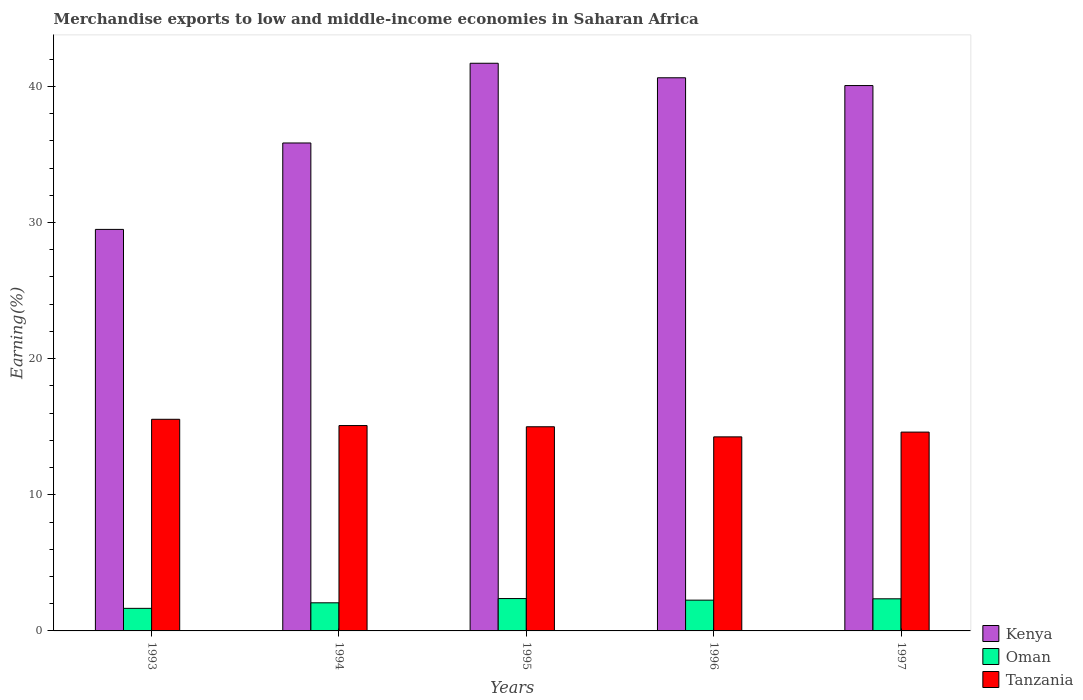How many groups of bars are there?
Give a very brief answer. 5. Are the number of bars on each tick of the X-axis equal?
Offer a very short reply. Yes. How many bars are there on the 2nd tick from the left?
Your answer should be compact. 3. How many bars are there on the 2nd tick from the right?
Keep it short and to the point. 3. What is the percentage of amount earned from merchandise exports in Oman in 1997?
Give a very brief answer. 2.36. Across all years, what is the maximum percentage of amount earned from merchandise exports in Kenya?
Ensure brevity in your answer.  41.7. Across all years, what is the minimum percentage of amount earned from merchandise exports in Oman?
Your answer should be very brief. 1.66. In which year was the percentage of amount earned from merchandise exports in Tanzania maximum?
Your response must be concise. 1993. In which year was the percentage of amount earned from merchandise exports in Tanzania minimum?
Provide a short and direct response. 1996. What is the total percentage of amount earned from merchandise exports in Oman in the graph?
Ensure brevity in your answer.  10.72. What is the difference between the percentage of amount earned from merchandise exports in Tanzania in 1994 and that in 1996?
Keep it short and to the point. 0.83. What is the difference between the percentage of amount earned from merchandise exports in Tanzania in 1993 and the percentage of amount earned from merchandise exports in Oman in 1997?
Ensure brevity in your answer.  13.19. What is the average percentage of amount earned from merchandise exports in Kenya per year?
Keep it short and to the point. 37.55. In the year 1993, what is the difference between the percentage of amount earned from merchandise exports in Kenya and percentage of amount earned from merchandise exports in Oman?
Your answer should be compact. 27.84. What is the ratio of the percentage of amount earned from merchandise exports in Tanzania in 1993 to that in 1997?
Give a very brief answer. 1.06. Is the percentage of amount earned from merchandise exports in Tanzania in 1995 less than that in 1997?
Your answer should be compact. No. What is the difference between the highest and the second highest percentage of amount earned from merchandise exports in Tanzania?
Provide a succinct answer. 0.46. What is the difference between the highest and the lowest percentage of amount earned from merchandise exports in Oman?
Keep it short and to the point. 0.72. In how many years, is the percentage of amount earned from merchandise exports in Oman greater than the average percentage of amount earned from merchandise exports in Oman taken over all years?
Provide a short and direct response. 3. Is the sum of the percentage of amount earned from merchandise exports in Kenya in 1996 and 1997 greater than the maximum percentage of amount earned from merchandise exports in Tanzania across all years?
Provide a short and direct response. Yes. What does the 2nd bar from the left in 1997 represents?
Offer a terse response. Oman. What does the 3rd bar from the right in 1995 represents?
Your answer should be very brief. Kenya. Is it the case that in every year, the sum of the percentage of amount earned from merchandise exports in Oman and percentage of amount earned from merchandise exports in Tanzania is greater than the percentage of amount earned from merchandise exports in Kenya?
Your answer should be very brief. No. What is the difference between two consecutive major ticks on the Y-axis?
Your answer should be compact. 10. Are the values on the major ticks of Y-axis written in scientific E-notation?
Make the answer very short. No. Does the graph contain any zero values?
Offer a terse response. No. Does the graph contain grids?
Make the answer very short. No. Where does the legend appear in the graph?
Give a very brief answer. Bottom right. What is the title of the graph?
Offer a very short reply. Merchandise exports to low and middle-income economies in Saharan Africa. Does "Virgin Islands" appear as one of the legend labels in the graph?
Make the answer very short. No. What is the label or title of the X-axis?
Ensure brevity in your answer.  Years. What is the label or title of the Y-axis?
Offer a very short reply. Earning(%). What is the Earning(%) in Kenya in 1993?
Your answer should be very brief. 29.49. What is the Earning(%) of Oman in 1993?
Offer a terse response. 1.66. What is the Earning(%) in Tanzania in 1993?
Give a very brief answer. 15.55. What is the Earning(%) in Kenya in 1994?
Your response must be concise. 35.84. What is the Earning(%) of Oman in 1994?
Offer a very short reply. 2.07. What is the Earning(%) in Tanzania in 1994?
Make the answer very short. 15.09. What is the Earning(%) in Kenya in 1995?
Offer a terse response. 41.7. What is the Earning(%) in Oman in 1995?
Provide a short and direct response. 2.38. What is the Earning(%) of Tanzania in 1995?
Offer a very short reply. 15. What is the Earning(%) in Kenya in 1996?
Offer a very short reply. 40.63. What is the Earning(%) of Oman in 1996?
Your response must be concise. 2.26. What is the Earning(%) of Tanzania in 1996?
Offer a terse response. 14.25. What is the Earning(%) of Kenya in 1997?
Offer a very short reply. 40.06. What is the Earning(%) of Oman in 1997?
Keep it short and to the point. 2.36. What is the Earning(%) of Tanzania in 1997?
Give a very brief answer. 14.61. Across all years, what is the maximum Earning(%) of Kenya?
Make the answer very short. 41.7. Across all years, what is the maximum Earning(%) of Oman?
Ensure brevity in your answer.  2.38. Across all years, what is the maximum Earning(%) of Tanzania?
Provide a succinct answer. 15.55. Across all years, what is the minimum Earning(%) of Kenya?
Ensure brevity in your answer.  29.49. Across all years, what is the minimum Earning(%) in Oman?
Provide a short and direct response. 1.66. Across all years, what is the minimum Earning(%) of Tanzania?
Your response must be concise. 14.25. What is the total Earning(%) in Kenya in the graph?
Keep it short and to the point. 187.73. What is the total Earning(%) of Oman in the graph?
Offer a very short reply. 10.72. What is the total Earning(%) of Tanzania in the graph?
Ensure brevity in your answer.  74.49. What is the difference between the Earning(%) in Kenya in 1993 and that in 1994?
Ensure brevity in your answer.  -6.35. What is the difference between the Earning(%) of Oman in 1993 and that in 1994?
Your answer should be compact. -0.41. What is the difference between the Earning(%) in Tanzania in 1993 and that in 1994?
Provide a succinct answer. 0.46. What is the difference between the Earning(%) of Kenya in 1993 and that in 1995?
Ensure brevity in your answer.  -12.2. What is the difference between the Earning(%) in Oman in 1993 and that in 1995?
Your answer should be compact. -0.72. What is the difference between the Earning(%) in Tanzania in 1993 and that in 1995?
Make the answer very short. 0.55. What is the difference between the Earning(%) in Kenya in 1993 and that in 1996?
Your answer should be compact. -11.14. What is the difference between the Earning(%) in Oman in 1993 and that in 1996?
Offer a very short reply. -0.6. What is the difference between the Earning(%) in Tanzania in 1993 and that in 1996?
Give a very brief answer. 1.29. What is the difference between the Earning(%) of Kenya in 1993 and that in 1997?
Give a very brief answer. -10.57. What is the difference between the Earning(%) in Oman in 1993 and that in 1997?
Your answer should be very brief. -0.7. What is the difference between the Earning(%) of Tanzania in 1993 and that in 1997?
Your response must be concise. 0.94. What is the difference between the Earning(%) of Kenya in 1994 and that in 1995?
Your answer should be very brief. -5.86. What is the difference between the Earning(%) in Oman in 1994 and that in 1995?
Give a very brief answer. -0.31. What is the difference between the Earning(%) of Tanzania in 1994 and that in 1995?
Provide a succinct answer. 0.09. What is the difference between the Earning(%) in Kenya in 1994 and that in 1996?
Provide a short and direct response. -4.79. What is the difference between the Earning(%) in Oman in 1994 and that in 1996?
Make the answer very short. -0.2. What is the difference between the Earning(%) in Tanzania in 1994 and that in 1996?
Keep it short and to the point. 0.83. What is the difference between the Earning(%) of Kenya in 1994 and that in 1997?
Give a very brief answer. -4.22. What is the difference between the Earning(%) of Oman in 1994 and that in 1997?
Provide a succinct answer. -0.29. What is the difference between the Earning(%) in Tanzania in 1994 and that in 1997?
Give a very brief answer. 0.48. What is the difference between the Earning(%) of Kenya in 1995 and that in 1996?
Provide a short and direct response. 1.07. What is the difference between the Earning(%) of Oman in 1995 and that in 1996?
Make the answer very short. 0.12. What is the difference between the Earning(%) of Tanzania in 1995 and that in 1996?
Your response must be concise. 0.74. What is the difference between the Earning(%) of Kenya in 1995 and that in 1997?
Give a very brief answer. 1.64. What is the difference between the Earning(%) in Oman in 1995 and that in 1997?
Your answer should be very brief. 0.02. What is the difference between the Earning(%) of Tanzania in 1995 and that in 1997?
Make the answer very short. 0.39. What is the difference between the Earning(%) in Oman in 1996 and that in 1997?
Your response must be concise. -0.1. What is the difference between the Earning(%) in Tanzania in 1996 and that in 1997?
Provide a short and direct response. -0.35. What is the difference between the Earning(%) in Kenya in 1993 and the Earning(%) in Oman in 1994?
Offer a terse response. 27.43. What is the difference between the Earning(%) in Kenya in 1993 and the Earning(%) in Tanzania in 1994?
Your response must be concise. 14.41. What is the difference between the Earning(%) of Oman in 1993 and the Earning(%) of Tanzania in 1994?
Your answer should be compact. -13.43. What is the difference between the Earning(%) of Kenya in 1993 and the Earning(%) of Oman in 1995?
Your answer should be compact. 27.12. What is the difference between the Earning(%) in Kenya in 1993 and the Earning(%) in Tanzania in 1995?
Offer a terse response. 14.5. What is the difference between the Earning(%) of Oman in 1993 and the Earning(%) of Tanzania in 1995?
Offer a very short reply. -13.34. What is the difference between the Earning(%) in Kenya in 1993 and the Earning(%) in Oman in 1996?
Keep it short and to the point. 27.23. What is the difference between the Earning(%) in Kenya in 1993 and the Earning(%) in Tanzania in 1996?
Your answer should be very brief. 15.24. What is the difference between the Earning(%) in Oman in 1993 and the Earning(%) in Tanzania in 1996?
Offer a very short reply. -12.6. What is the difference between the Earning(%) of Kenya in 1993 and the Earning(%) of Oman in 1997?
Offer a terse response. 27.14. What is the difference between the Earning(%) in Kenya in 1993 and the Earning(%) in Tanzania in 1997?
Provide a succinct answer. 14.89. What is the difference between the Earning(%) of Oman in 1993 and the Earning(%) of Tanzania in 1997?
Provide a succinct answer. -12.95. What is the difference between the Earning(%) of Kenya in 1994 and the Earning(%) of Oman in 1995?
Your answer should be compact. 33.46. What is the difference between the Earning(%) in Kenya in 1994 and the Earning(%) in Tanzania in 1995?
Ensure brevity in your answer.  20.85. What is the difference between the Earning(%) of Oman in 1994 and the Earning(%) of Tanzania in 1995?
Offer a very short reply. -12.93. What is the difference between the Earning(%) of Kenya in 1994 and the Earning(%) of Oman in 1996?
Ensure brevity in your answer.  33.58. What is the difference between the Earning(%) in Kenya in 1994 and the Earning(%) in Tanzania in 1996?
Your answer should be compact. 21.59. What is the difference between the Earning(%) in Oman in 1994 and the Earning(%) in Tanzania in 1996?
Offer a very short reply. -12.19. What is the difference between the Earning(%) of Kenya in 1994 and the Earning(%) of Oman in 1997?
Keep it short and to the point. 33.48. What is the difference between the Earning(%) of Kenya in 1994 and the Earning(%) of Tanzania in 1997?
Make the answer very short. 21.24. What is the difference between the Earning(%) in Oman in 1994 and the Earning(%) in Tanzania in 1997?
Ensure brevity in your answer.  -12.54. What is the difference between the Earning(%) in Kenya in 1995 and the Earning(%) in Oman in 1996?
Ensure brevity in your answer.  39.44. What is the difference between the Earning(%) in Kenya in 1995 and the Earning(%) in Tanzania in 1996?
Offer a very short reply. 27.44. What is the difference between the Earning(%) in Oman in 1995 and the Earning(%) in Tanzania in 1996?
Provide a short and direct response. -11.88. What is the difference between the Earning(%) of Kenya in 1995 and the Earning(%) of Oman in 1997?
Provide a succinct answer. 39.34. What is the difference between the Earning(%) in Kenya in 1995 and the Earning(%) in Tanzania in 1997?
Offer a terse response. 27.09. What is the difference between the Earning(%) of Oman in 1995 and the Earning(%) of Tanzania in 1997?
Your answer should be compact. -12.23. What is the difference between the Earning(%) of Kenya in 1996 and the Earning(%) of Oman in 1997?
Your answer should be compact. 38.27. What is the difference between the Earning(%) of Kenya in 1996 and the Earning(%) of Tanzania in 1997?
Make the answer very short. 26.03. What is the difference between the Earning(%) in Oman in 1996 and the Earning(%) in Tanzania in 1997?
Make the answer very short. -12.34. What is the average Earning(%) of Kenya per year?
Make the answer very short. 37.55. What is the average Earning(%) in Oman per year?
Offer a terse response. 2.14. What is the average Earning(%) in Tanzania per year?
Ensure brevity in your answer.  14.9. In the year 1993, what is the difference between the Earning(%) of Kenya and Earning(%) of Oman?
Give a very brief answer. 27.84. In the year 1993, what is the difference between the Earning(%) of Kenya and Earning(%) of Tanzania?
Ensure brevity in your answer.  13.95. In the year 1993, what is the difference between the Earning(%) of Oman and Earning(%) of Tanzania?
Offer a very short reply. -13.89. In the year 1994, what is the difference between the Earning(%) in Kenya and Earning(%) in Oman?
Keep it short and to the point. 33.78. In the year 1994, what is the difference between the Earning(%) of Kenya and Earning(%) of Tanzania?
Offer a terse response. 20.76. In the year 1994, what is the difference between the Earning(%) in Oman and Earning(%) in Tanzania?
Offer a terse response. -13.02. In the year 1995, what is the difference between the Earning(%) in Kenya and Earning(%) in Oman?
Make the answer very short. 39.32. In the year 1995, what is the difference between the Earning(%) of Kenya and Earning(%) of Tanzania?
Give a very brief answer. 26.7. In the year 1995, what is the difference between the Earning(%) in Oman and Earning(%) in Tanzania?
Keep it short and to the point. -12.62. In the year 1996, what is the difference between the Earning(%) in Kenya and Earning(%) in Oman?
Your answer should be compact. 38.37. In the year 1996, what is the difference between the Earning(%) of Kenya and Earning(%) of Tanzania?
Provide a succinct answer. 26.38. In the year 1996, what is the difference between the Earning(%) of Oman and Earning(%) of Tanzania?
Ensure brevity in your answer.  -11.99. In the year 1997, what is the difference between the Earning(%) of Kenya and Earning(%) of Oman?
Your response must be concise. 37.7. In the year 1997, what is the difference between the Earning(%) of Kenya and Earning(%) of Tanzania?
Your response must be concise. 25.46. In the year 1997, what is the difference between the Earning(%) in Oman and Earning(%) in Tanzania?
Keep it short and to the point. -12.25. What is the ratio of the Earning(%) in Kenya in 1993 to that in 1994?
Provide a short and direct response. 0.82. What is the ratio of the Earning(%) of Oman in 1993 to that in 1994?
Your answer should be very brief. 0.8. What is the ratio of the Earning(%) of Tanzania in 1993 to that in 1994?
Ensure brevity in your answer.  1.03. What is the ratio of the Earning(%) of Kenya in 1993 to that in 1995?
Offer a terse response. 0.71. What is the ratio of the Earning(%) of Oman in 1993 to that in 1995?
Offer a terse response. 0.7. What is the ratio of the Earning(%) of Tanzania in 1993 to that in 1995?
Keep it short and to the point. 1.04. What is the ratio of the Earning(%) in Kenya in 1993 to that in 1996?
Keep it short and to the point. 0.73. What is the ratio of the Earning(%) of Oman in 1993 to that in 1996?
Ensure brevity in your answer.  0.73. What is the ratio of the Earning(%) of Tanzania in 1993 to that in 1996?
Provide a succinct answer. 1.09. What is the ratio of the Earning(%) of Kenya in 1993 to that in 1997?
Offer a terse response. 0.74. What is the ratio of the Earning(%) of Oman in 1993 to that in 1997?
Your response must be concise. 0.7. What is the ratio of the Earning(%) of Tanzania in 1993 to that in 1997?
Ensure brevity in your answer.  1.06. What is the ratio of the Earning(%) in Kenya in 1994 to that in 1995?
Your answer should be very brief. 0.86. What is the ratio of the Earning(%) of Oman in 1994 to that in 1995?
Give a very brief answer. 0.87. What is the ratio of the Earning(%) in Tanzania in 1994 to that in 1995?
Your response must be concise. 1.01. What is the ratio of the Earning(%) of Kenya in 1994 to that in 1996?
Offer a very short reply. 0.88. What is the ratio of the Earning(%) in Oman in 1994 to that in 1996?
Your answer should be compact. 0.91. What is the ratio of the Earning(%) of Tanzania in 1994 to that in 1996?
Provide a succinct answer. 1.06. What is the ratio of the Earning(%) in Kenya in 1994 to that in 1997?
Your answer should be very brief. 0.89. What is the ratio of the Earning(%) of Oman in 1994 to that in 1997?
Your response must be concise. 0.88. What is the ratio of the Earning(%) in Tanzania in 1994 to that in 1997?
Give a very brief answer. 1.03. What is the ratio of the Earning(%) in Kenya in 1995 to that in 1996?
Your response must be concise. 1.03. What is the ratio of the Earning(%) in Oman in 1995 to that in 1996?
Offer a very short reply. 1.05. What is the ratio of the Earning(%) of Tanzania in 1995 to that in 1996?
Make the answer very short. 1.05. What is the ratio of the Earning(%) of Kenya in 1995 to that in 1997?
Your response must be concise. 1.04. What is the ratio of the Earning(%) of Oman in 1995 to that in 1997?
Give a very brief answer. 1.01. What is the ratio of the Earning(%) in Tanzania in 1995 to that in 1997?
Your answer should be very brief. 1.03. What is the ratio of the Earning(%) in Kenya in 1996 to that in 1997?
Offer a terse response. 1.01. What is the ratio of the Earning(%) of Oman in 1996 to that in 1997?
Your answer should be very brief. 0.96. What is the ratio of the Earning(%) in Tanzania in 1996 to that in 1997?
Ensure brevity in your answer.  0.98. What is the difference between the highest and the second highest Earning(%) in Kenya?
Your answer should be very brief. 1.07. What is the difference between the highest and the second highest Earning(%) of Oman?
Ensure brevity in your answer.  0.02. What is the difference between the highest and the second highest Earning(%) of Tanzania?
Offer a terse response. 0.46. What is the difference between the highest and the lowest Earning(%) in Kenya?
Make the answer very short. 12.2. What is the difference between the highest and the lowest Earning(%) of Oman?
Ensure brevity in your answer.  0.72. What is the difference between the highest and the lowest Earning(%) in Tanzania?
Your response must be concise. 1.29. 